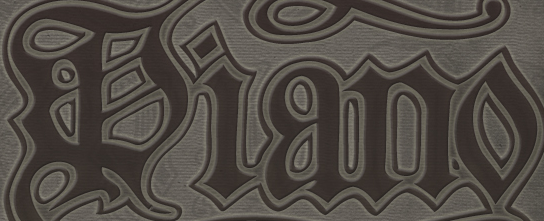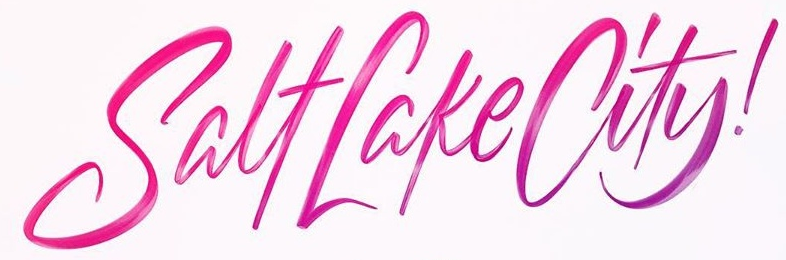What words are shown in these images in order, separated by a semicolon? Piano; SalfLakeCity! 